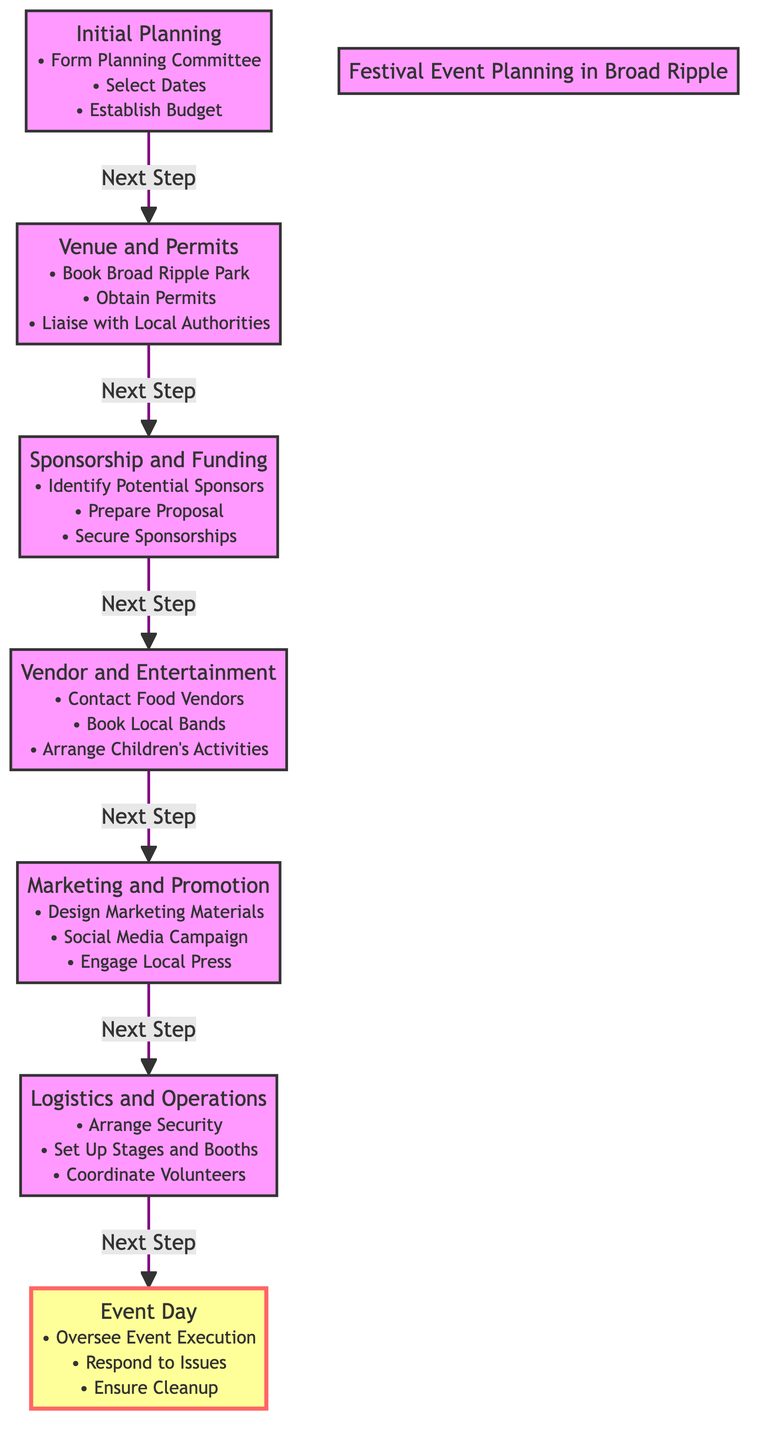What are the first three tasks listed in the diagram? The first three tasks in the diagram are part of the "Initial Planning" section and include "Form Planning Committee," "Select Dates," and "Establish Budget." These tasks represent the beginning steps of festival event planning in Broad Ripple.
Answer: Form Planning Committee, Select Dates, Establish Budget How many main steps are there in the event planning process? By counting the distinct tasks in the diagram, there are a total of seven main steps listed from “Initial Planning” to “Event Day.” These steps outline the sequential flow of the event planning activities.
Answer: Seven Which task directly follows "Sponsorship and Funding"? From the flow of the diagram, "Vendor and Entertainment" is the task that directly follows "Sponsorship and Funding." This establishes the progression of planning from obtaining funding to arranging vendors and entertainment.
Answer: Vendor and Entertainment What is the final task on the timeline? The last task in the sequence is "Event Day," which encompasses the overall execution, issue response, and cleanup of the event being planned. This indicates that all previous tasks lead up to this final day of execution.
Answer: Event Day Which nodes are connected by the arrow from "Marketing and Promotion"? The arrow from "Marketing and Promotion" points to "Logistics and Operations," indicating that after marketing efforts are made, the focus shifts to logistical arrangements and operational tasks for the event.
Answer: Logistics and Operations What color is the "Event Day" task represented in the diagram? In the diagram, the "Event Day" task is filled with a yellow color and has a red outline, indicated as designated by the class "eventDay." This visual distinction emphasizes the significance of the event day itself compared to other planning tasks.
Answer: Yellow with red outline Which task involves contacting local vendors and booking entertainment? The "Vendor and Entertainment" task involves contacting food vendors, booking local bands, and arranging children’s activities, making it essential for gathering entertainment for the event.
Answer: Vendor and Entertainment What action is to be taken immediately after obtaining permits? The action to be taken after obtaining permits is to liaise with local authorities, as noted in the “Venue and Permits” section of the diagram. This step is critical in ensuring compliance and cooperation for the event.
Answer: Liaise with Local Authorities 